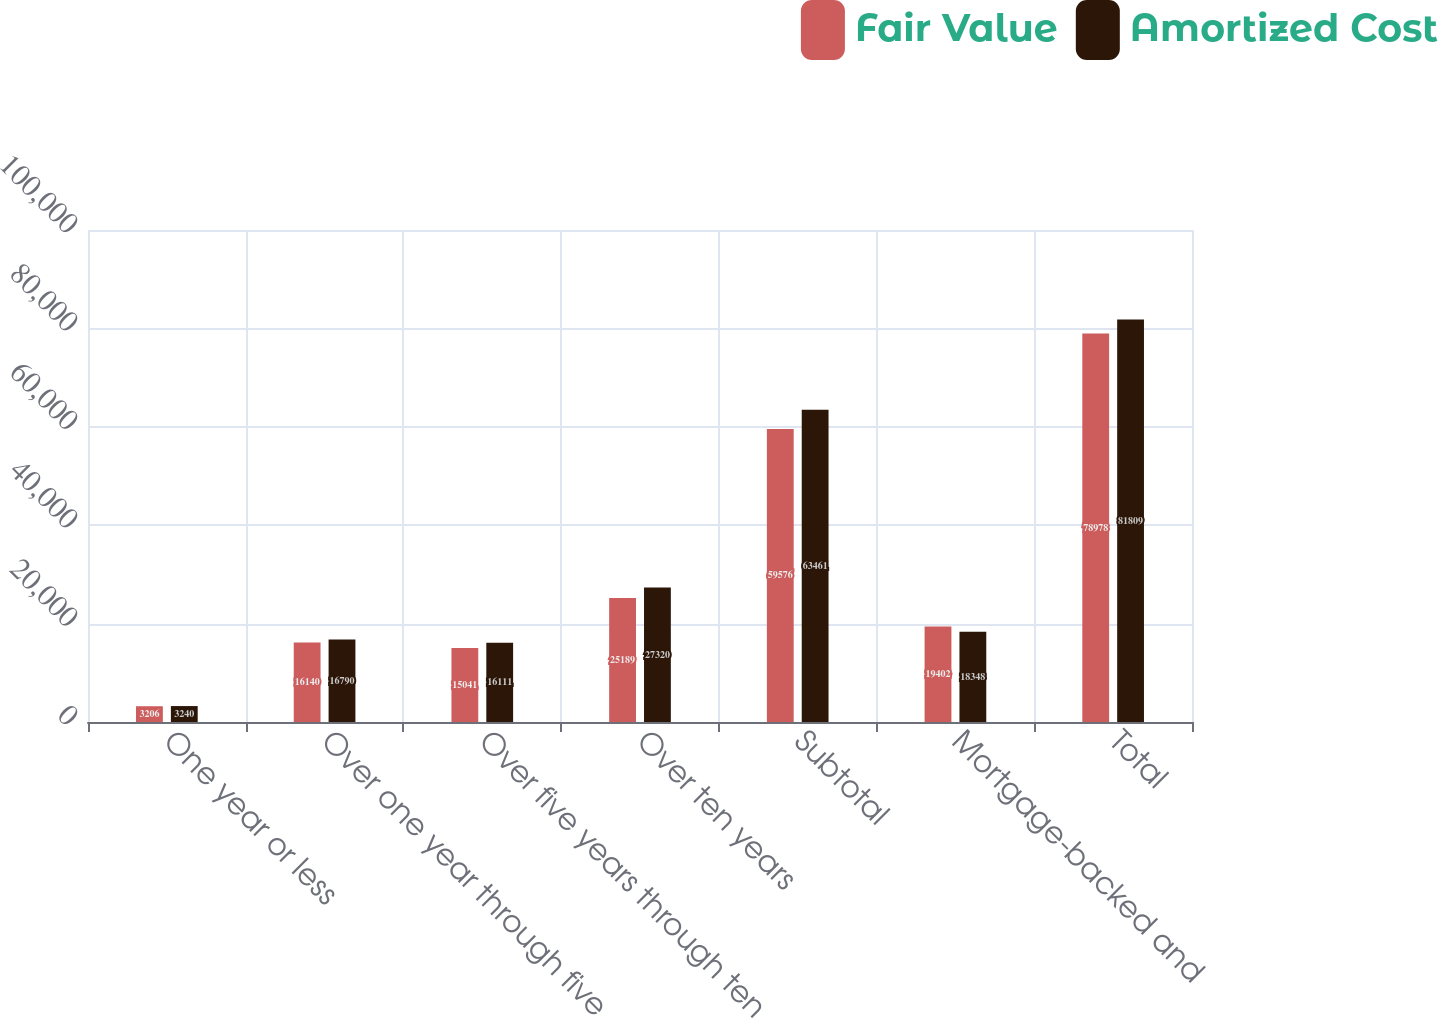<chart> <loc_0><loc_0><loc_500><loc_500><stacked_bar_chart><ecel><fcel>One year or less<fcel>Over one year through five<fcel>Over five years through ten<fcel>Over ten years<fcel>Subtotal<fcel>Mortgage-backed and<fcel>Total<nl><fcel>Fair Value<fcel>3206<fcel>16140<fcel>15041<fcel>25189<fcel>59576<fcel>19402<fcel>78978<nl><fcel>Amortized Cost<fcel>3240<fcel>16790<fcel>16111<fcel>27320<fcel>63461<fcel>18348<fcel>81809<nl></chart> 